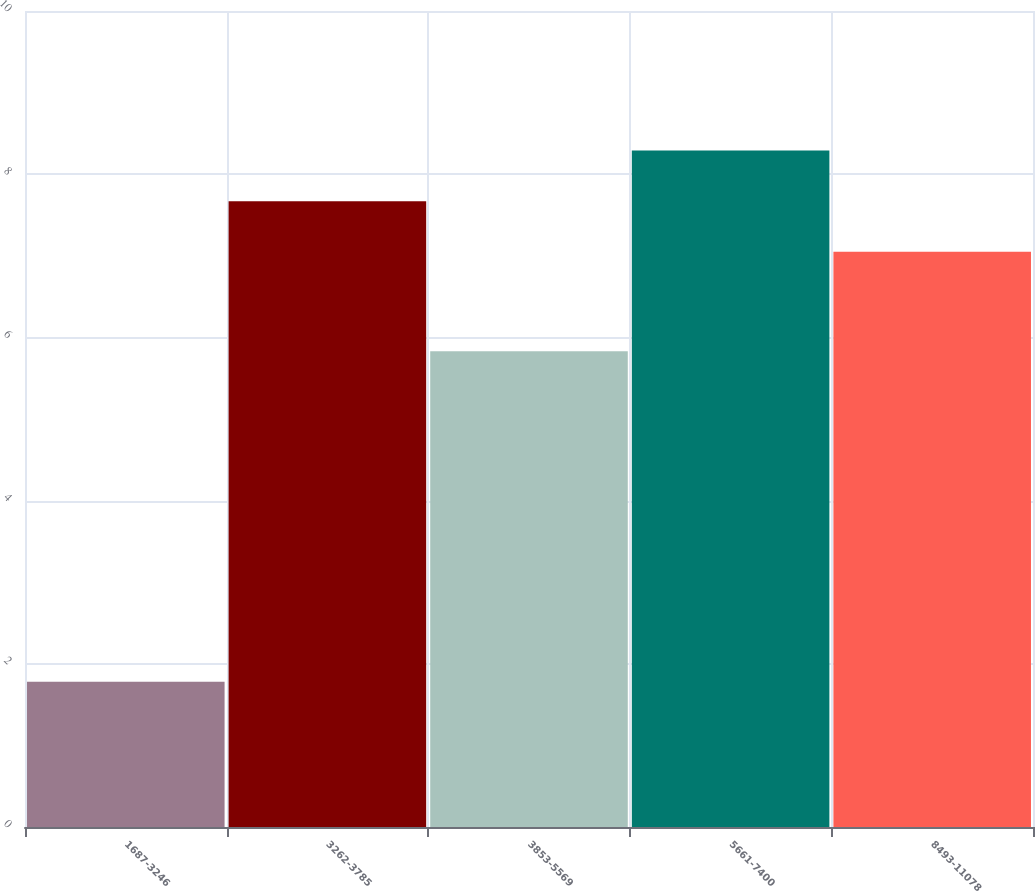<chart> <loc_0><loc_0><loc_500><loc_500><bar_chart><fcel>1687-3246<fcel>3262-3785<fcel>3853-5569<fcel>5661-7400<fcel>8493-11078<nl><fcel>1.78<fcel>7.67<fcel>5.83<fcel>8.29<fcel>7.05<nl></chart> 